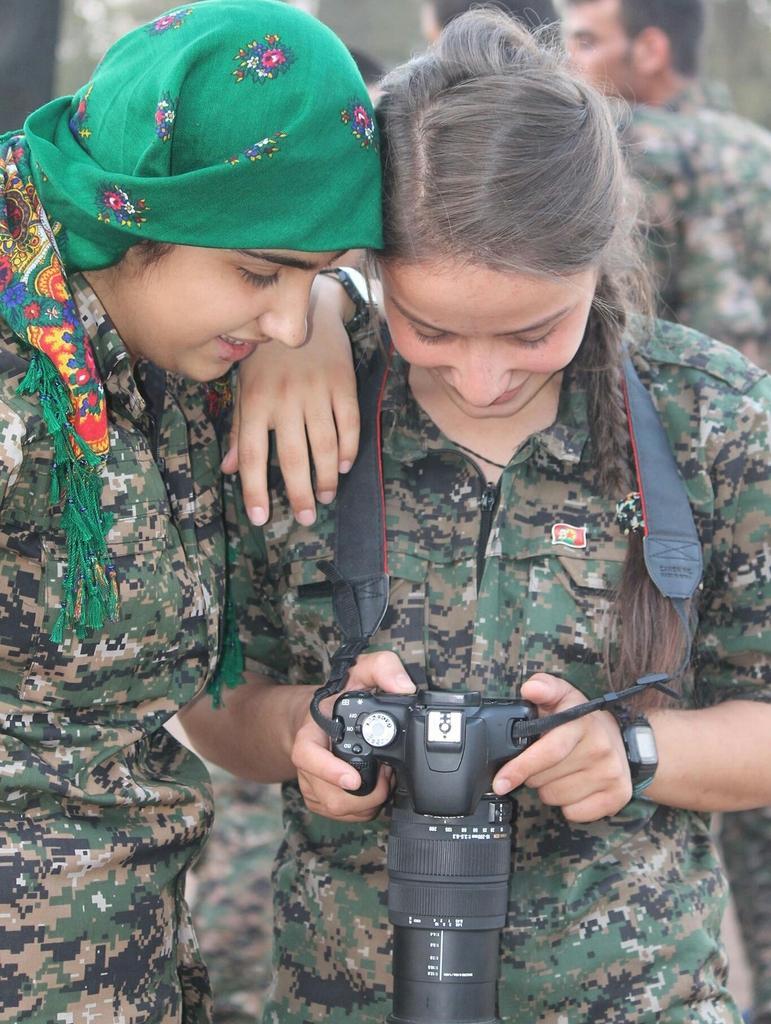Describe this image in one or two sentences. In the foreground of this picture we can see the two persons wearing uniforms and standing and we can see a camera. In the background we can see the group of persons wearing uniforms and some other objects. 